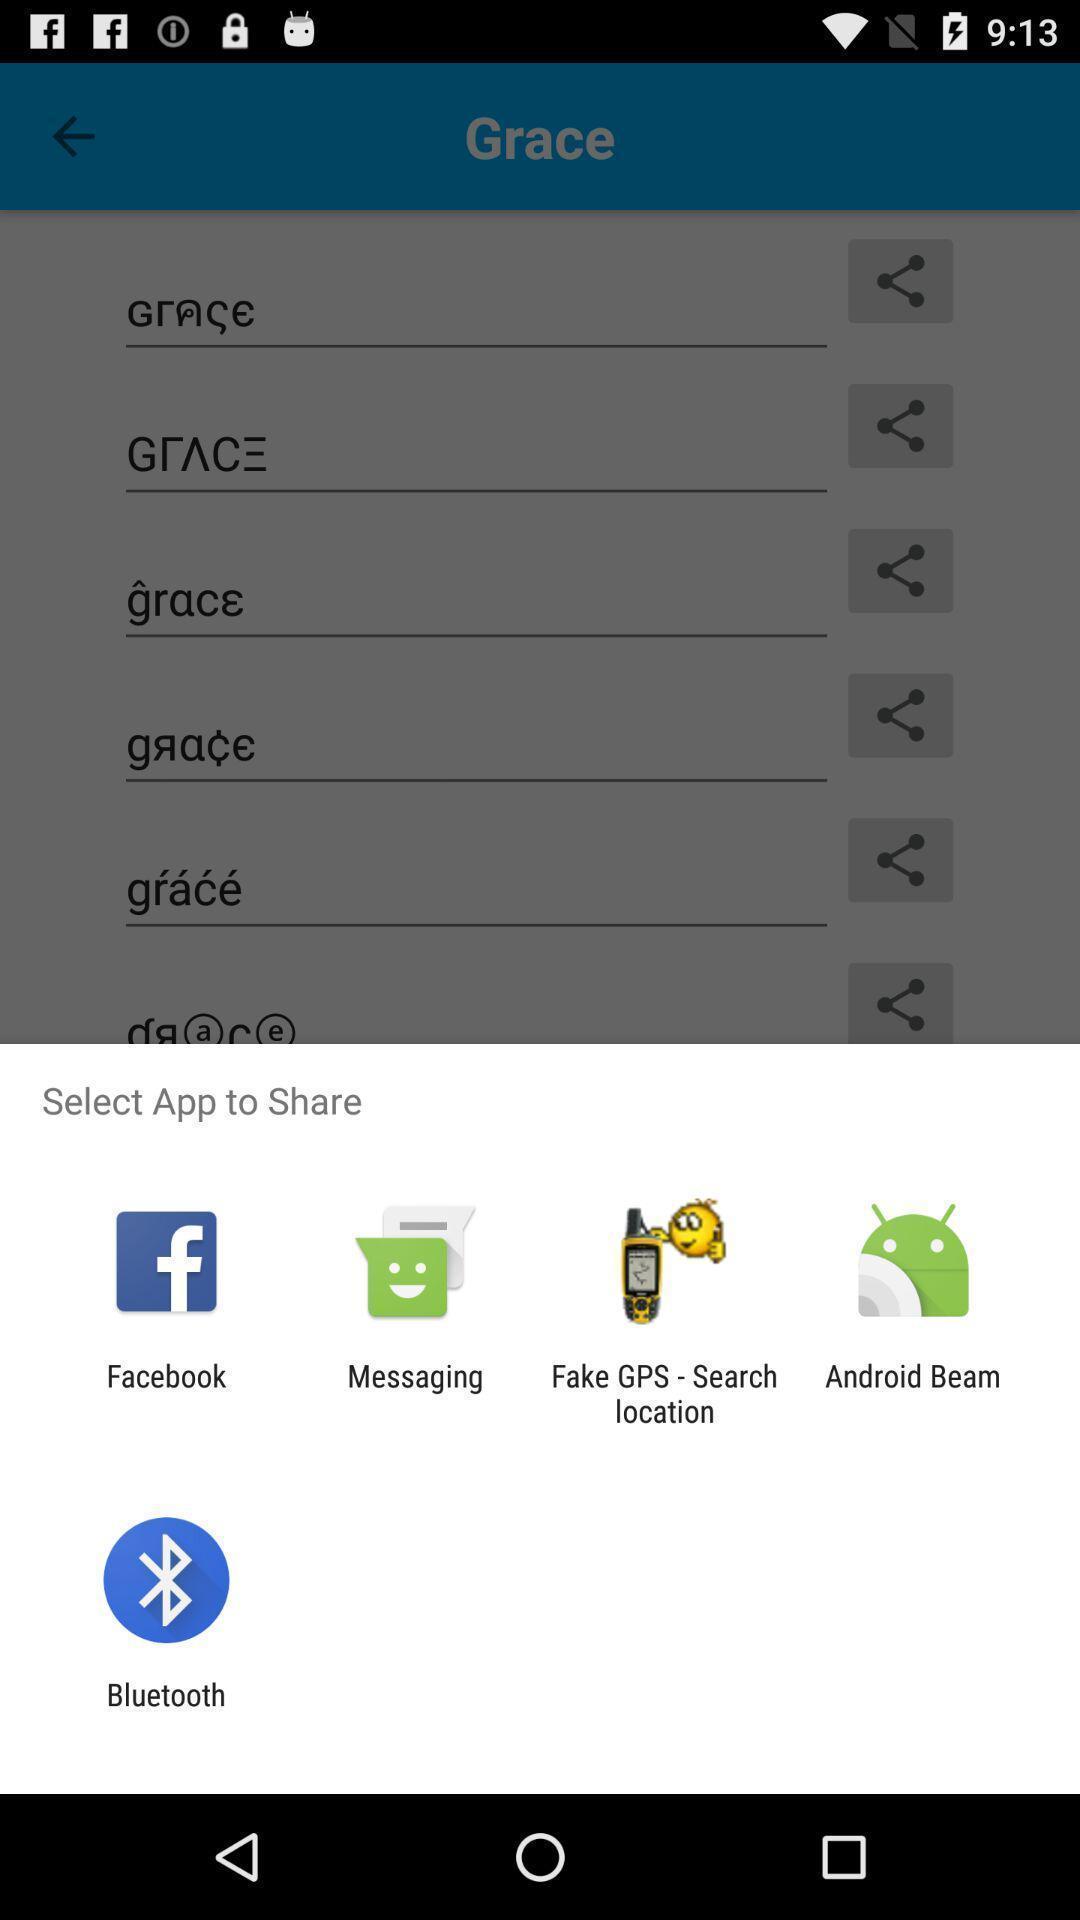Describe the key features of this screenshot. Popup to share. 